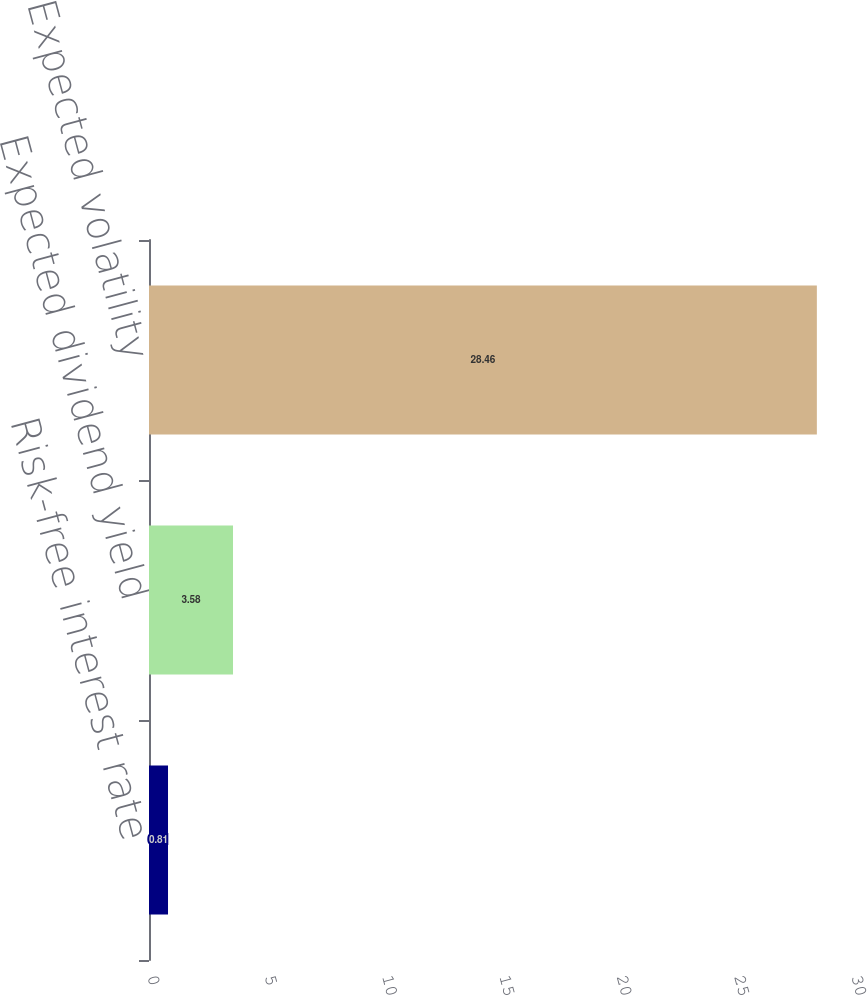Convert chart. <chart><loc_0><loc_0><loc_500><loc_500><bar_chart><fcel>Risk-free interest rate<fcel>Expected dividend yield<fcel>Expected volatility<nl><fcel>0.81<fcel>3.58<fcel>28.46<nl></chart> 